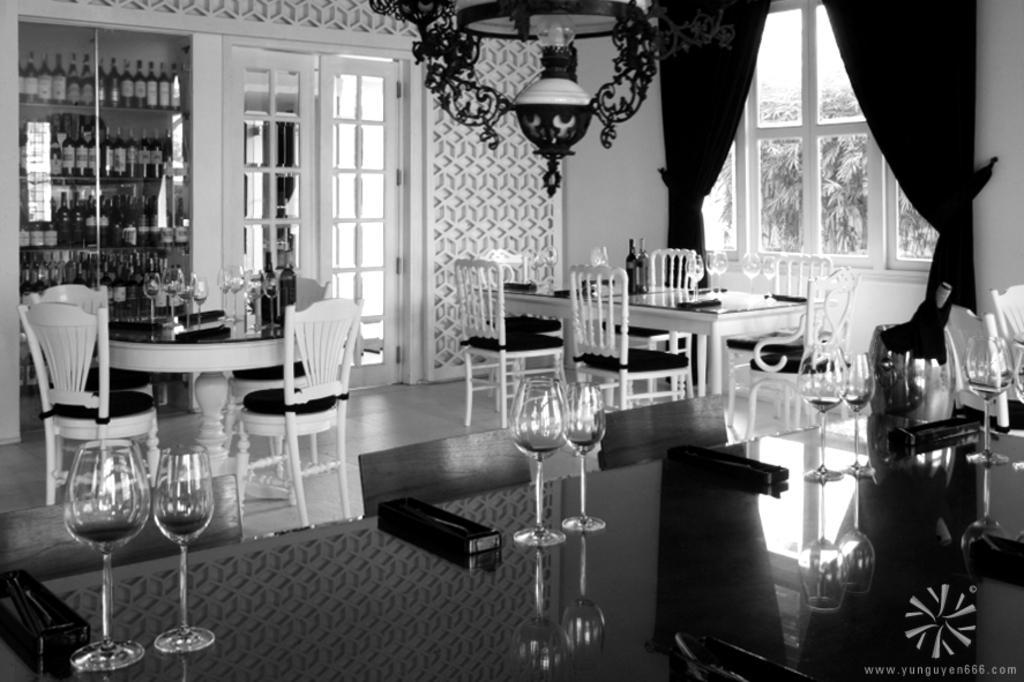Describe this image in one or two sentences. This is a black and white image. In this image we can see bottles arranged in shelves, door, windows, dining table, chairs, glass tumblers, beverage bottles, table, curtains, light and wall. 